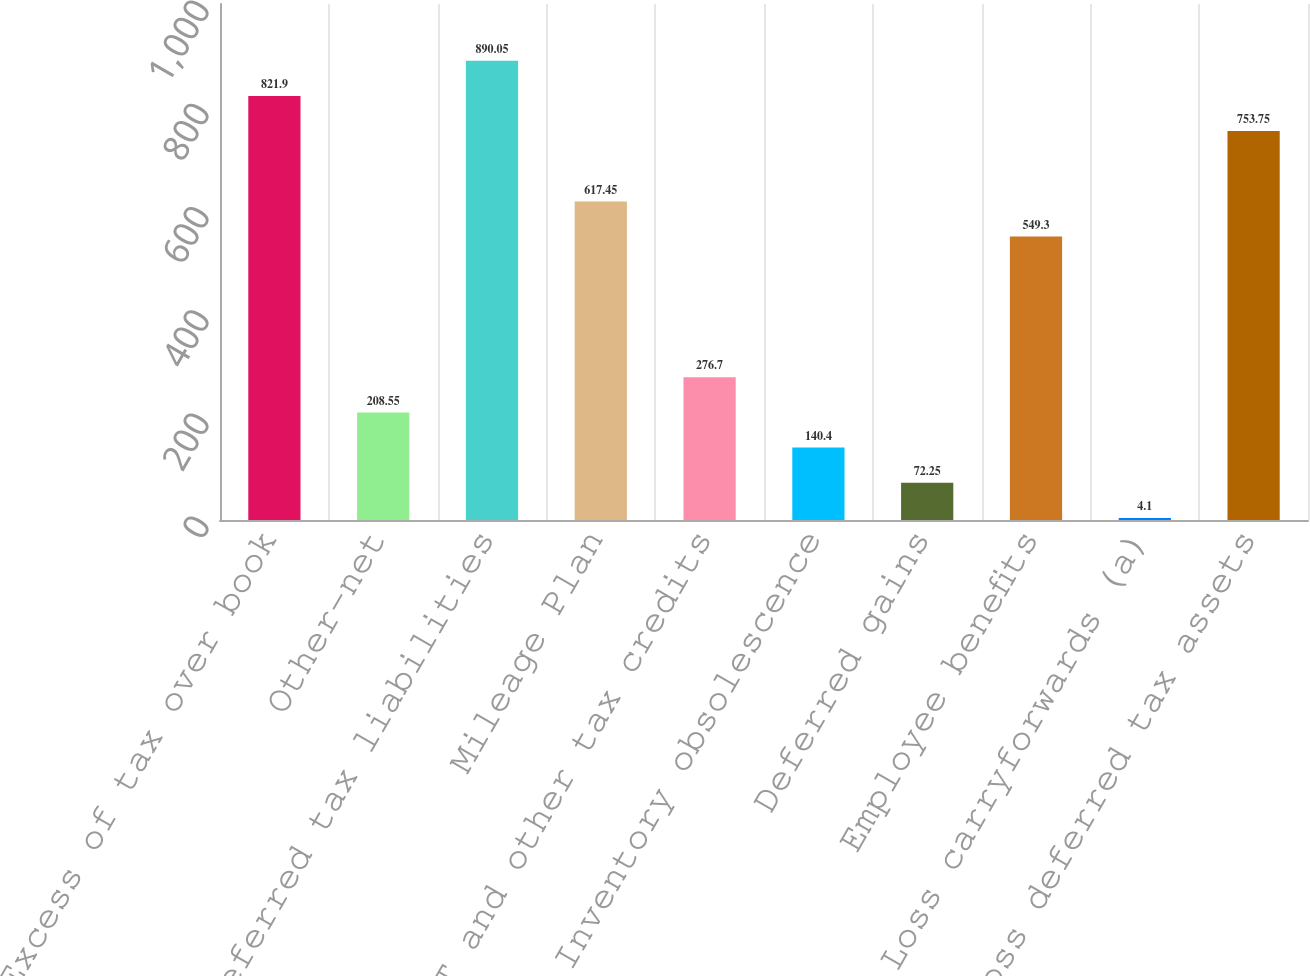Convert chart to OTSL. <chart><loc_0><loc_0><loc_500><loc_500><bar_chart><fcel>Excess of tax over book<fcel>Other-net<fcel>Gross deferred tax liabilities<fcel>Mileage Plan<fcel>AMT and other tax credits<fcel>Inventory obsolescence<fcel>Deferred gains<fcel>Employee benefits<fcel>Loss carryforwards (a)<fcel>Gross deferred tax assets<nl><fcel>821.9<fcel>208.55<fcel>890.05<fcel>617.45<fcel>276.7<fcel>140.4<fcel>72.25<fcel>549.3<fcel>4.1<fcel>753.75<nl></chart> 